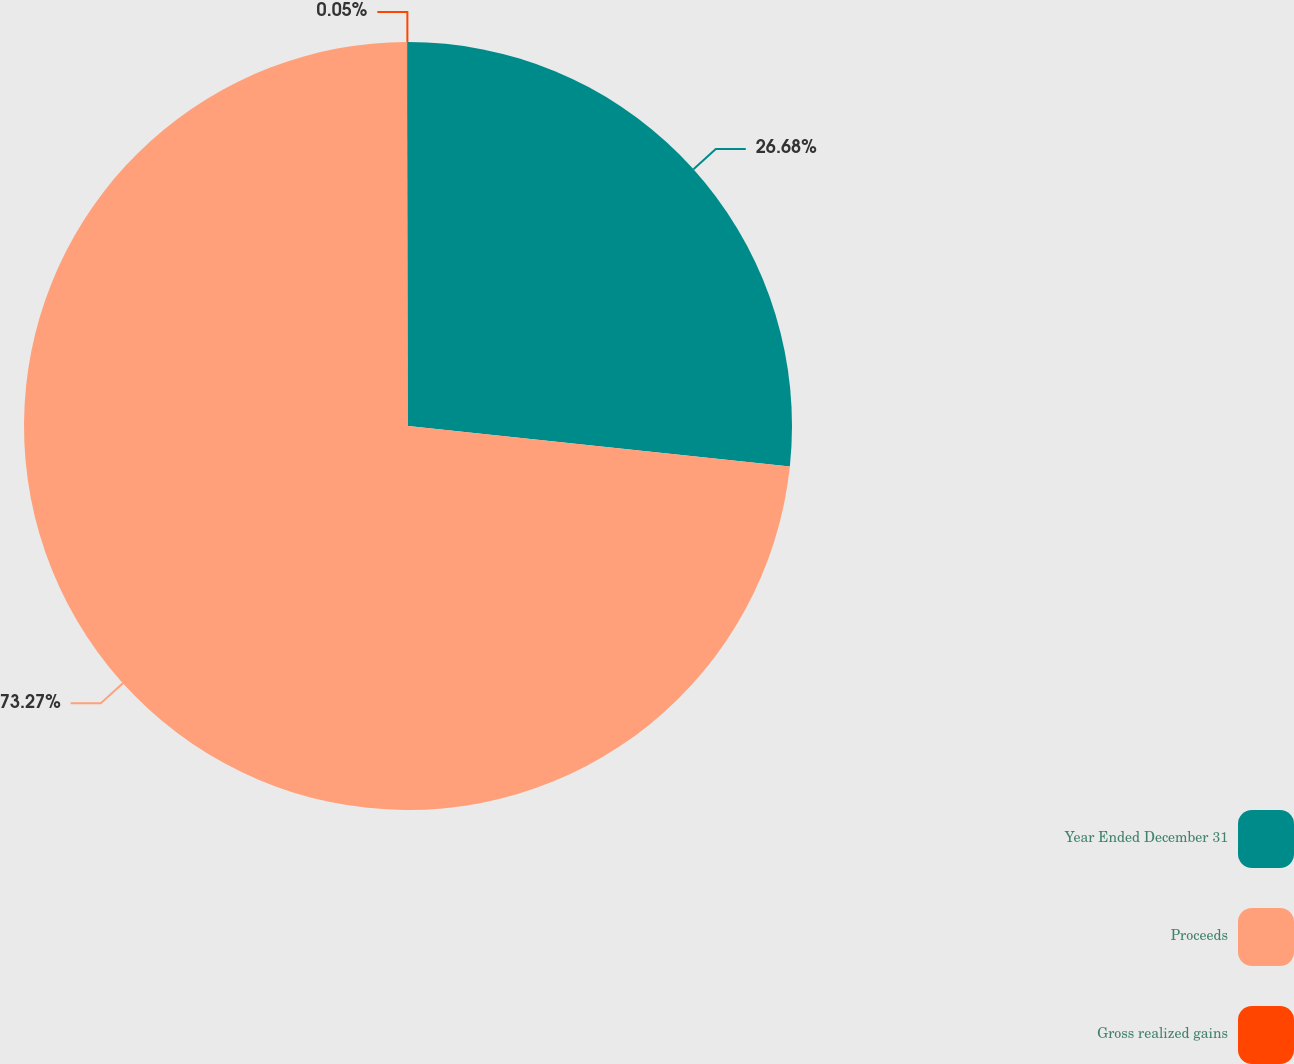Convert chart to OTSL. <chart><loc_0><loc_0><loc_500><loc_500><pie_chart><fcel>Year Ended December 31<fcel>Proceeds<fcel>Gross realized gains<nl><fcel>26.68%<fcel>73.27%<fcel>0.05%<nl></chart> 